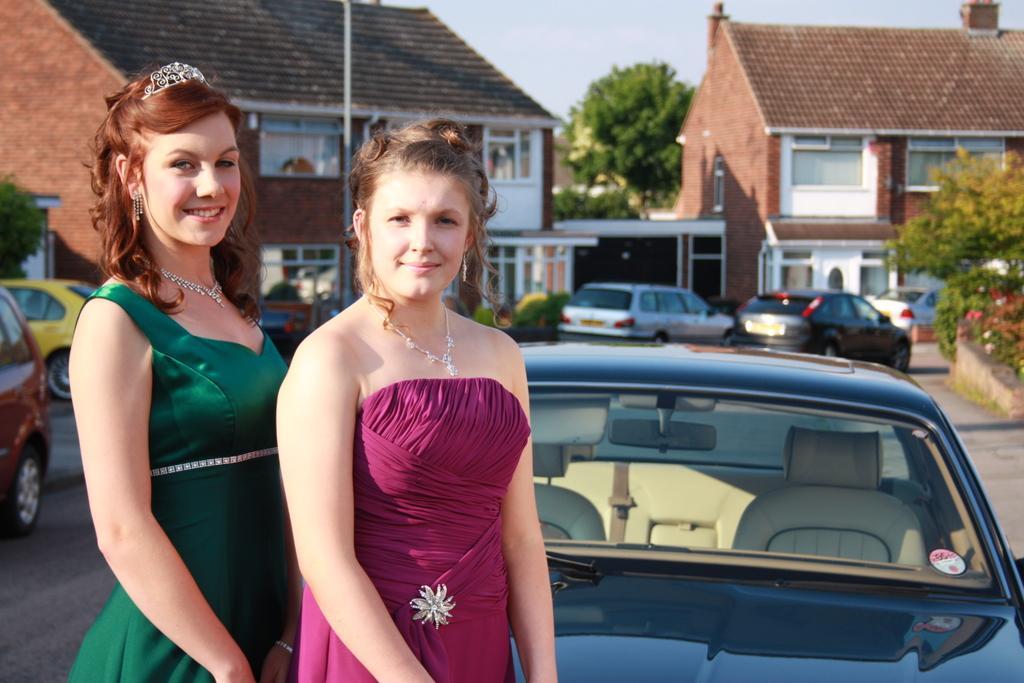Please provide a concise description of this image. In this picture there is a woman who is wearing red color dress and necklace. Beside her we can see another woman who is wearing a necklace, green color dress and hearings. Both of them are standing near to the car. On the background we can see buildings cars, trees and plants. On the top there is a sky. On the right we can see plant. 